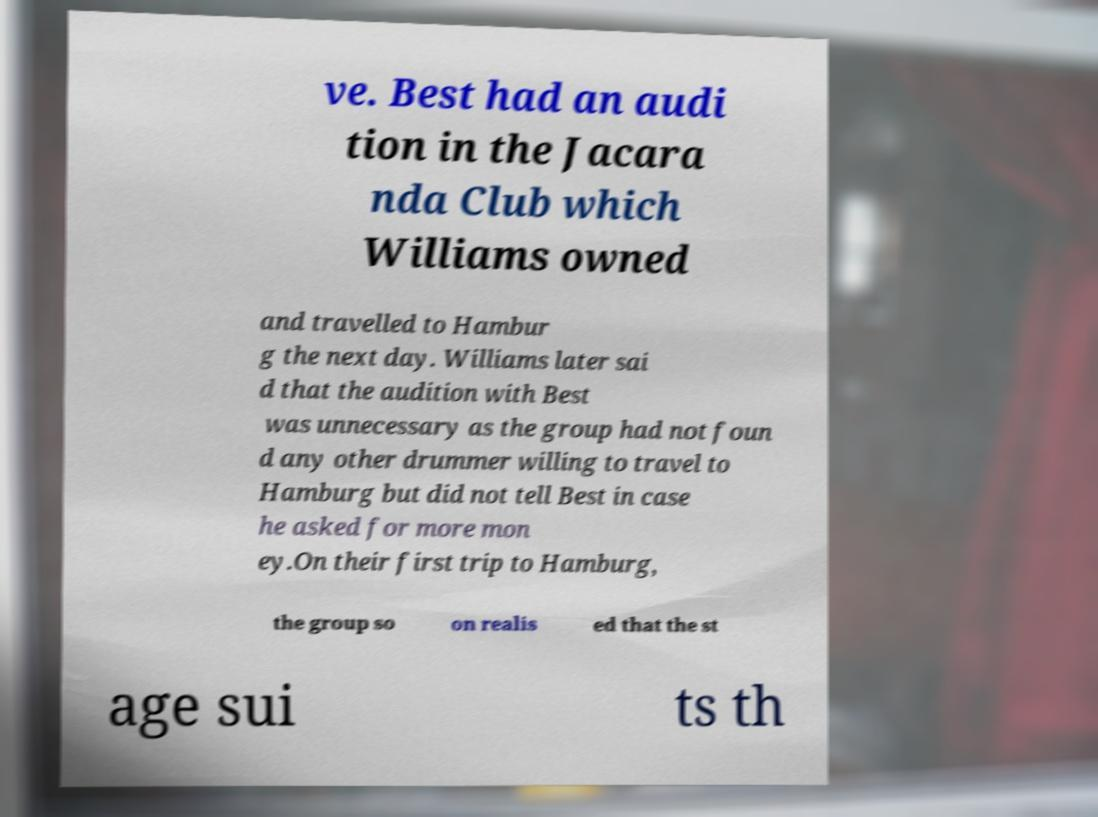Could you assist in decoding the text presented in this image and type it out clearly? ve. Best had an audi tion in the Jacara nda Club which Williams owned and travelled to Hambur g the next day. Williams later sai d that the audition with Best was unnecessary as the group had not foun d any other drummer willing to travel to Hamburg but did not tell Best in case he asked for more mon ey.On their first trip to Hamburg, the group so on realis ed that the st age sui ts th 